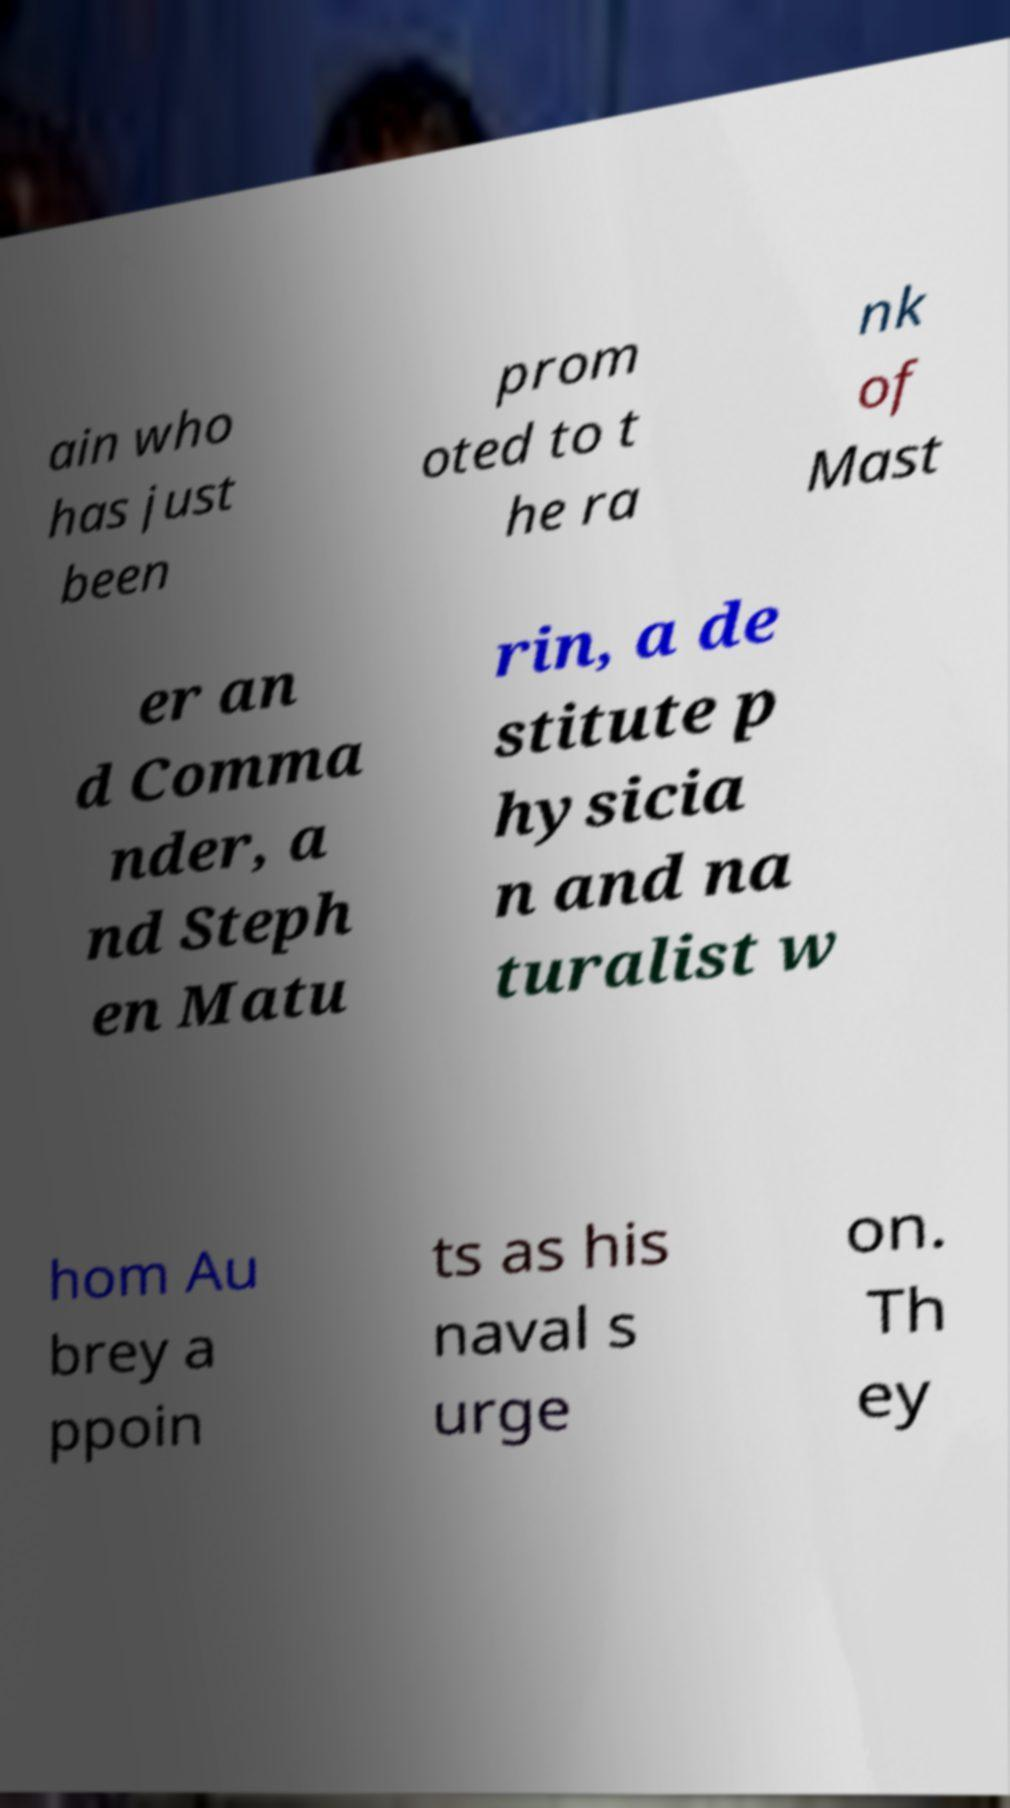Please read and relay the text visible in this image. What does it say? ain who has just been prom oted to t he ra nk of Mast er an d Comma nder, a nd Steph en Matu rin, a de stitute p hysicia n and na turalist w hom Au brey a ppoin ts as his naval s urge on. Th ey 